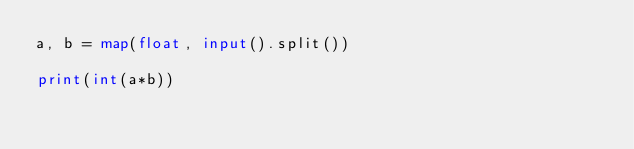<code> <loc_0><loc_0><loc_500><loc_500><_Python_>a, b = map(float, input().split())

print(int(a*b))</code> 